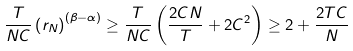Convert formula to latex. <formula><loc_0><loc_0><loc_500><loc_500>\frac { T } { N C } \left ( r _ { N } \right ) ^ { \left ( \beta - \alpha \right ) } \geq \frac { T } { N C } \left ( \frac { 2 C N } { T } + 2 C ^ { 2 } \right ) \geq 2 + \frac { 2 T C } { N }</formula> 